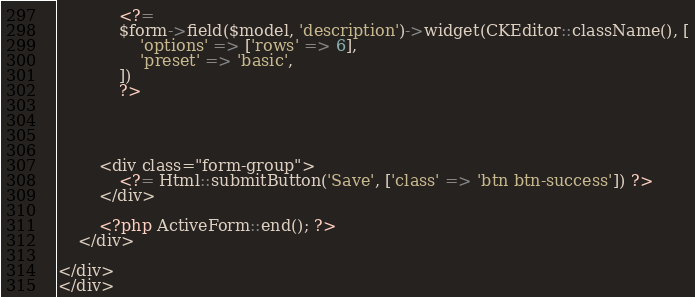<code> <loc_0><loc_0><loc_500><loc_500><_PHP_>            <?=
            $form->field($model, 'description')->widget(CKEditor::className(), [
                'options' => ['rows' => 6],
                'preset' => 'basic',
            ])
            ?>




        <div class="form-group">
            <?= Html::submitButton('Save', ['class' => 'btn btn-success']) ?>
        </div>

        <?php ActiveForm::end(); ?>
    </div>

</div>
</div>
</code> 